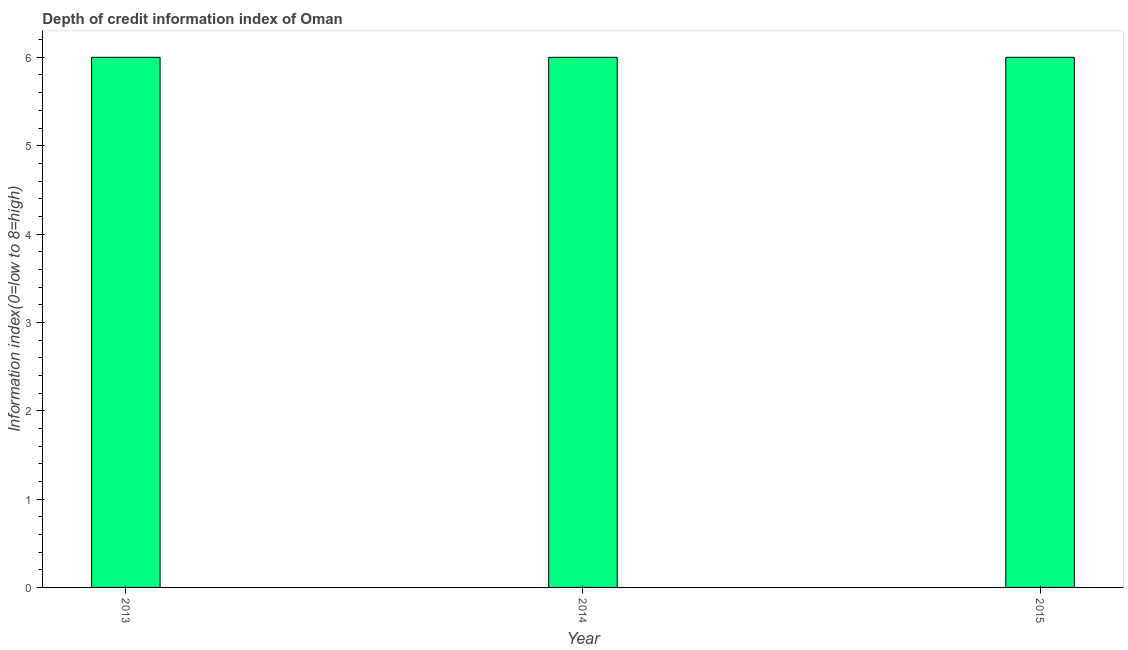Does the graph contain any zero values?
Offer a terse response. No. What is the title of the graph?
Ensure brevity in your answer.  Depth of credit information index of Oman. What is the label or title of the Y-axis?
Give a very brief answer. Information index(0=low to 8=high). What is the depth of credit information index in 2013?
Give a very brief answer. 6. In which year was the depth of credit information index maximum?
Offer a very short reply. 2013. In which year was the depth of credit information index minimum?
Make the answer very short. 2013. What is the difference between the depth of credit information index in 2013 and 2014?
Offer a very short reply. 0. What is the ratio of the depth of credit information index in 2014 to that in 2015?
Offer a very short reply. 1. Is the difference between the depth of credit information index in 2014 and 2015 greater than the difference between any two years?
Provide a short and direct response. Yes. What is the difference between the highest and the second highest depth of credit information index?
Your answer should be very brief. 0. Is the sum of the depth of credit information index in 2013 and 2014 greater than the maximum depth of credit information index across all years?
Make the answer very short. Yes. What is the difference between the highest and the lowest depth of credit information index?
Your response must be concise. 0. How many bars are there?
Offer a very short reply. 3. How many years are there in the graph?
Your response must be concise. 3. Are the values on the major ticks of Y-axis written in scientific E-notation?
Keep it short and to the point. No. What is the Information index(0=low to 8=high) of 2013?
Offer a very short reply. 6. What is the difference between the Information index(0=low to 8=high) in 2013 and 2014?
Your answer should be very brief. 0. What is the difference between the Information index(0=low to 8=high) in 2013 and 2015?
Keep it short and to the point. 0. What is the ratio of the Information index(0=low to 8=high) in 2013 to that in 2015?
Provide a succinct answer. 1. What is the ratio of the Information index(0=low to 8=high) in 2014 to that in 2015?
Keep it short and to the point. 1. 